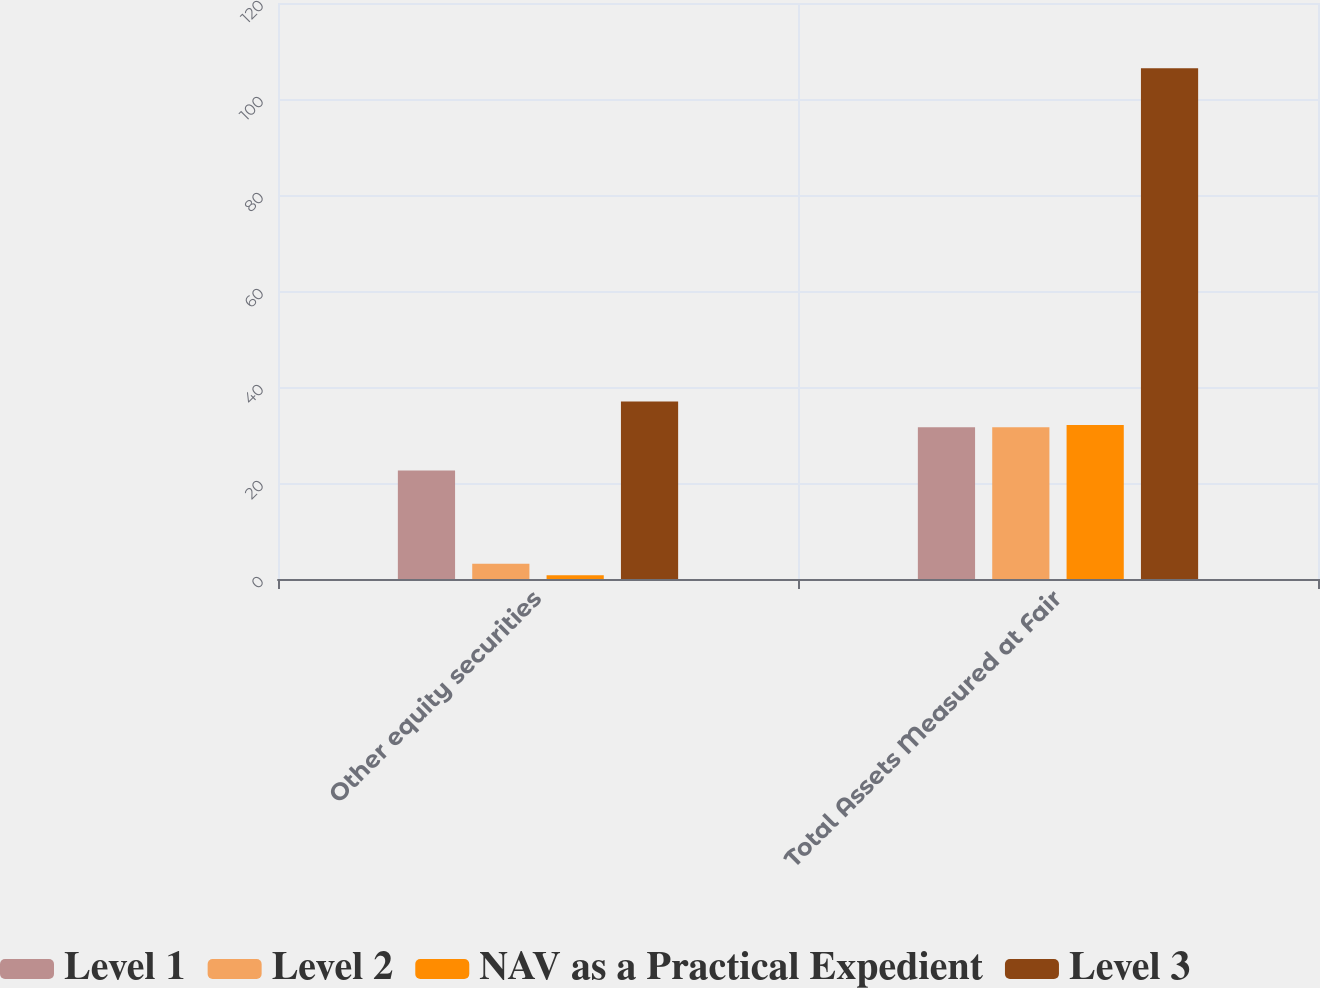Convert chart. <chart><loc_0><loc_0><loc_500><loc_500><stacked_bar_chart><ecel><fcel>Other equity securities<fcel>Total Assets Measured at Fair<nl><fcel>Level 1<fcel>22.6<fcel>31.6<nl><fcel>Level 2<fcel>3.2<fcel>31.6<nl><fcel>NAV as a Practical Expedient<fcel>0.8<fcel>32.1<nl><fcel>Level 3<fcel>37<fcel>106.4<nl></chart> 